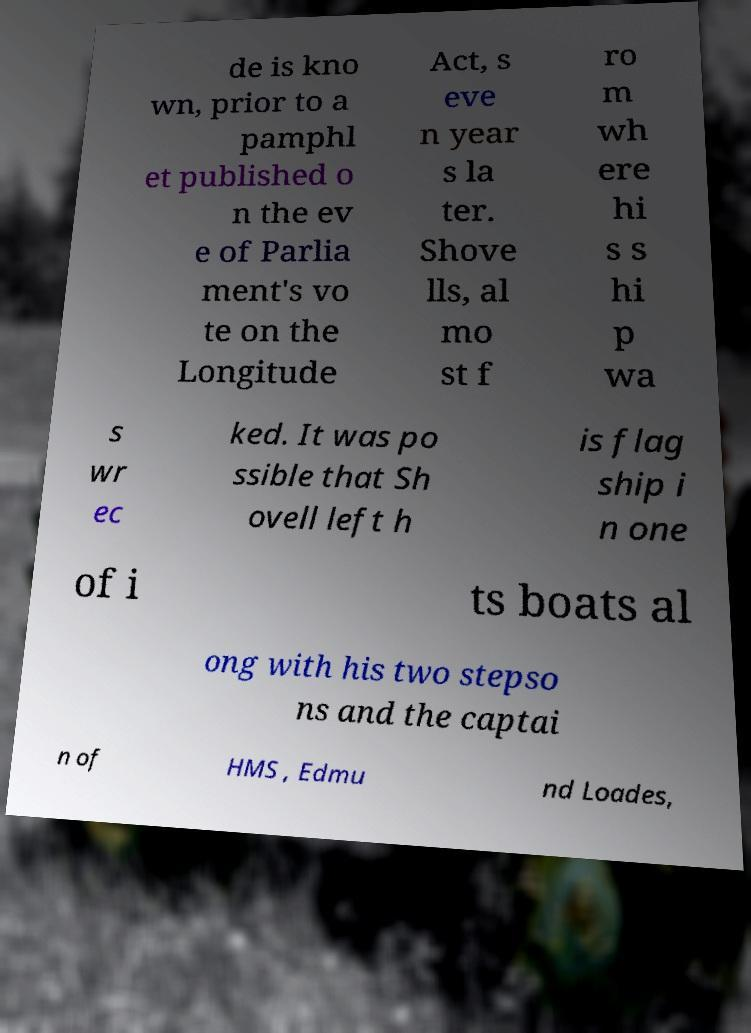There's text embedded in this image that I need extracted. Can you transcribe it verbatim? de is kno wn, prior to a pamphl et published o n the ev e of Parlia ment's vo te on the Longitude Act, s eve n year s la ter. Shove lls, al mo st f ro m wh ere hi s s hi p wa s wr ec ked. It was po ssible that Sh ovell left h is flag ship i n one of i ts boats al ong with his two stepso ns and the captai n of HMS , Edmu nd Loades, 